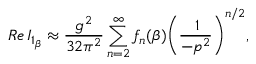<formula> <loc_0><loc_0><loc_500><loc_500>R e \, I _ { 1 _ { \beta } } \approx \frac { g ^ { 2 } } { 3 2 \pi ^ { 2 } } \sum _ { n = 2 } ^ { \infty } f _ { n } ( \beta ) \left ( \frac { \, 1 } { - p ^ { 2 } } \right ) ^ { n / 2 } ,</formula> 